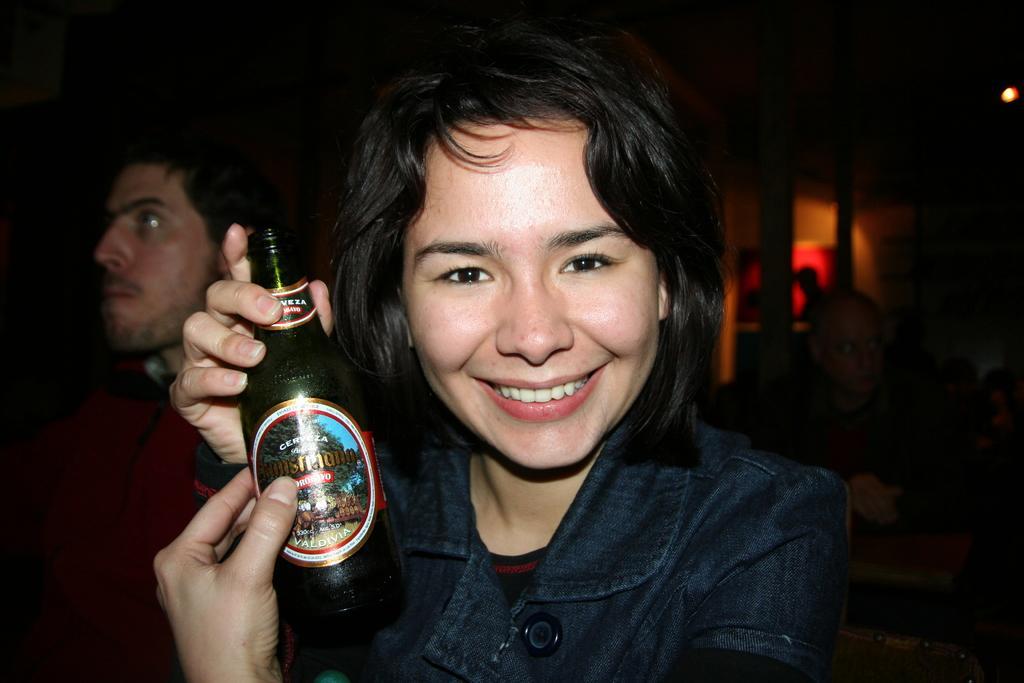In one or two sentences, can you explain what this image depicts? This picture shows a woman holding a beer bottle in her hand and we see a smile on her face and we see a man on the side 